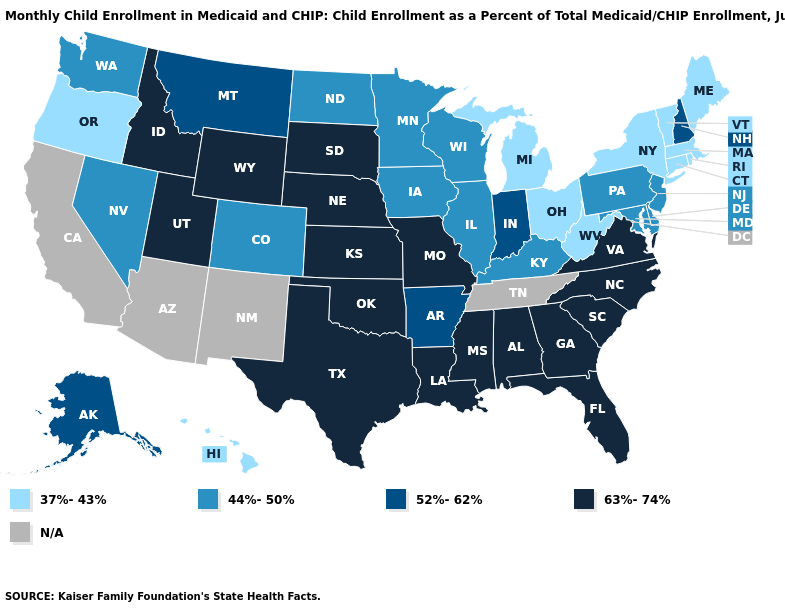What is the lowest value in states that border Montana?
Short answer required. 44%-50%. Among the states that border Kansas , does Missouri have the lowest value?
Answer briefly. No. Which states have the highest value in the USA?
Be succinct. Alabama, Florida, Georgia, Idaho, Kansas, Louisiana, Mississippi, Missouri, Nebraska, North Carolina, Oklahoma, South Carolina, South Dakota, Texas, Utah, Virginia, Wyoming. What is the value of Utah?
Quick response, please. 63%-74%. Among the states that border Mississippi , which have the highest value?
Keep it brief. Alabama, Louisiana. Which states have the highest value in the USA?
Short answer required. Alabama, Florida, Georgia, Idaho, Kansas, Louisiana, Mississippi, Missouri, Nebraska, North Carolina, Oklahoma, South Carolina, South Dakota, Texas, Utah, Virginia, Wyoming. Which states have the highest value in the USA?
Write a very short answer. Alabama, Florida, Georgia, Idaho, Kansas, Louisiana, Mississippi, Missouri, Nebraska, North Carolina, Oklahoma, South Carolina, South Dakota, Texas, Utah, Virginia, Wyoming. Among the states that border Wisconsin , does Iowa have the lowest value?
Give a very brief answer. No. Name the states that have a value in the range 44%-50%?
Concise answer only. Colorado, Delaware, Illinois, Iowa, Kentucky, Maryland, Minnesota, Nevada, New Jersey, North Dakota, Pennsylvania, Washington, Wisconsin. Name the states that have a value in the range 44%-50%?
Write a very short answer. Colorado, Delaware, Illinois, Iowa, Kentucky, Maryland, Minnesota, Nevada, New Jersey, North Dakota, Pennsylvania, Washington, Wisconsin. What is the lowest value in states that border Montana?
Be succinct. 44%-50%. What is the value of Florida?
Write a very short answer. 63%-74%. Which states have the highest value in the USA?
Answer briefly. Alabama, Florida, Georgia, Idaho, Kansas, Louisiana, Mississippi, Missouri, Nebraska, North Carolina, Oklahoma, South Carolina, South Dakota, Texas, Utah, Virginia, Wyoming. What is the value of Illinois?
Quick response, please. 44%-50%. 